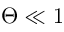Convert formula to latex. <formula><loc_0><loc_0><loc_500><loc_500>\Theta \ll 1</formula> 